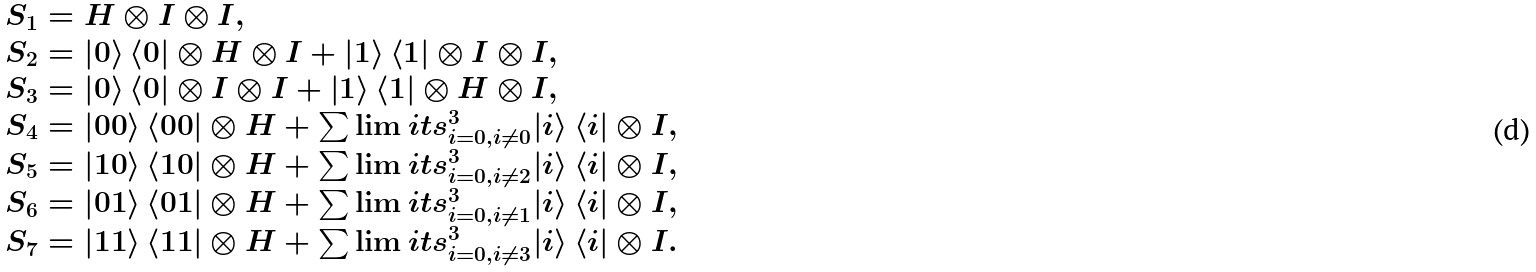Convert formula to latex. <formula><loc_0><loc_0><loc_500><loc_500>\begin{array} { l } S _ { 1 } = H \otimes I \otimes I , \\ S _ { 2 } = \left | 0 \right \rangle \left \langle 0 \right | \otimes H \otimes I + \left | 1 \right \rangle \left \langle 1 \right | \otimes I \otimes I , \\ S _ { 3 } = \left | 0 \right \rangle \left \langle 0 \right | \otimes I \otimes I + \left | 1 \right \rangle \left \langle 1 \right | \otimes H \otimes I , \\ S _ { 4 } = \left | { 0 0 } \right \rangle \left \langle { 0 0 } \right | \otimes H + \sum \lim i t s _ { i = 0 , i \ne 0 } ^ { 3 } { \left | i \right \rangle \left \langle i \right | } \otimes I , \\ S _ { 5 } = \left | { 1 0 } \right \rangle \left \langle { 1 0 } \right | \otimes H + \sum \lim i t s _ { i = 0 , i \ne 2 } ^ { 3 } { \left | i \right \rangle \left \langle i \right | } \otimes I , \\ S _ { 6 } = \left | { 0 1 } \right \rangle \left \langle { 0 1 } \right | \otimes H + \sum \lim i t s _ { i = 0 , i \ne 1 } ^ { 3 } { \left | i \right \rangle \left \langle i \right | } \otimes I , \\ S _ { 7 } = \left | { 1 1 } \right \rangle \left \langle { 1 1 } \right | \otimes H + \sum \lim i t s _ { i = 0 , i \ne 3 } ^ { 3 } { \left | i \right \rangle \left \langle i \right | } \otimes I . \\ \end{array}</formula> 